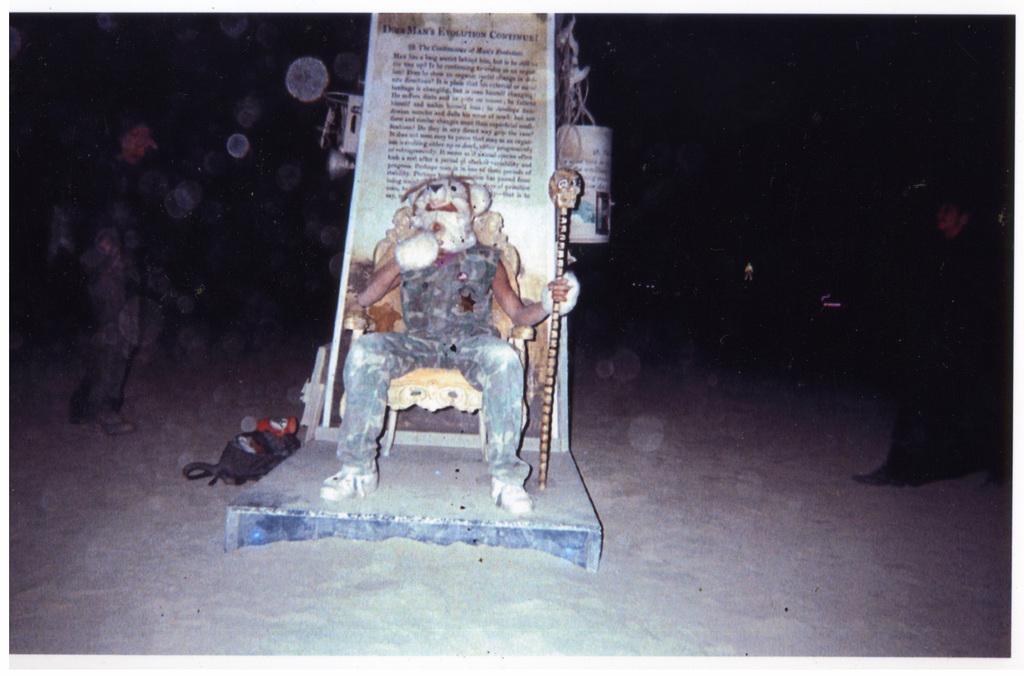In one or two sentences, can you explain what this image depicts? In the image we can see there is a person who is sitting on chair and he is wearing a teddy bear mask on his head and he is holding a skull which is attached on a bamboo stick and on the either sides of the person there are men who are standing. 